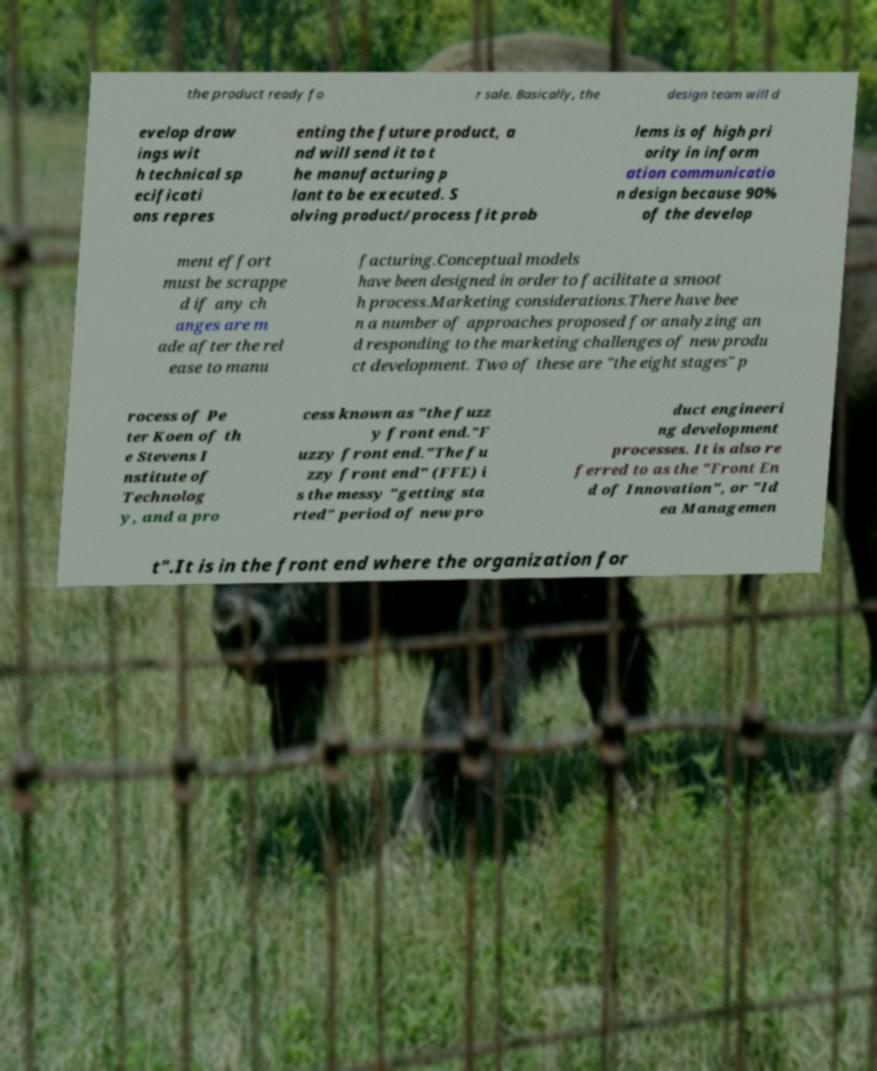Could you assist in decoding the text presented in this image and type it out clearly? the product ready fo r sale. Basically, the design team will d evelop draw ings wit h technical sp ecificati ons repres enting the future product, a nd will send it to t he manufacturing p lant to be executed. S olving product/process fit prob lems is of high pri ority in inform ation communicatio n design because 90% of the develop ment effort must be scrappe d if any ch anges are m ade after the rel ease to manu facturing.Conceptual models have been designed in order to facilitate a smoot h process.Marketing considerations.There have bee n a number of approaches proposed for analyzing an d responding to the marketing challenges of new produ ct development. Two of these are "the eight stages" p rocess of Pe ter Koen of th e Stevens I nstitute of Technolog y, and a pro cess known as "the fuzz y front end."F uzzy front end."The fu zzy front end" (FFE) i s the messy "getting sta rted" period of new pro duct engineeri ng development processes. It is also re ferred to as the "Front En d of Innovation", or "Id ea Managemen t".It is in the front end where the organization for 